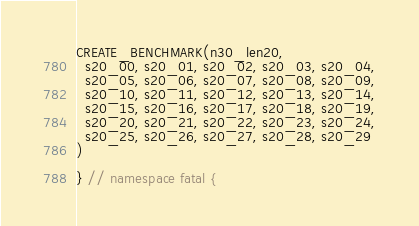Convert code to text. <code><loc_0><loc_0><loc_500><loc_500><_C++_>CREATE_BENCHMARK(n30_len20,
  s20_00, s20_01, s20_02, s20_03, s20_04,
  s20_05, s20_06, s20_07, s20_08, s20_09,
  s20_10, s20_11, s20_12, s20_13, s20_14,
  s20_15, s20_16, s20_17, s20_18, s20_19,
  s20_20, s20_21, s20_22, s20_23, s20_24,
  s20_25, s20_26, s20_27, s20_28, s20_29
)

} // namespace fatal {
</code> 